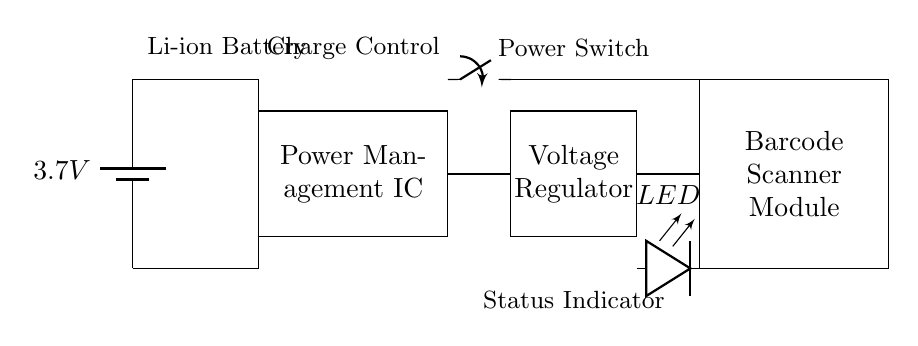What is the voltage of the battery? The circuit shows a battery labeled with a voltage of 3.7 volts, which is the potential difference provided by the battery.
Answer: 3.7V What component regulates the voltage? The Voltage Regulator is identified in the circuit diagram as the component responsible for regulating voltage to the Barcode Scanner Module.
Answer: Voltage Regulator What does the LED indicate? The LED serves as a status indicator in the circuit, showing whether the system is powered on or functioning.
Answer: Status Indicator What is the main function of the Power Management IC? The Power Management IC is shown as a component that connects the battery to both the voltage regulator and the switch, implying it manages the distribution of power within the circuit.
Answer: Charge Control How does the power flow from the battery to the barcode scanner? The power flows from the battery to the Power Management IC, then to the Voltage Regulator, which finally supplies the Barcode Scanner Module, indicating a series connection of these components.
Answer: Series Connection What role does the power switch play in this circuit? The Power Switch allows for the control of power delivery from the Power Management IC to the rest of the circuit, indicating whether the device is on or off.
Answer: Control Power Delivery What type of battery is used in this circuit? The battery is indicated as a Li-ion battery, which is commonly used for portable devices due to its efficiency and rechargeability.
Answer: Li-ion Battery 